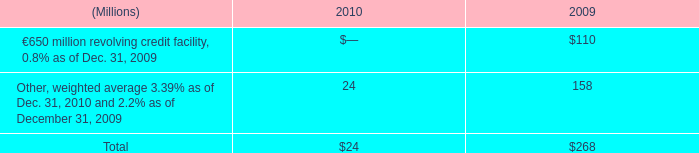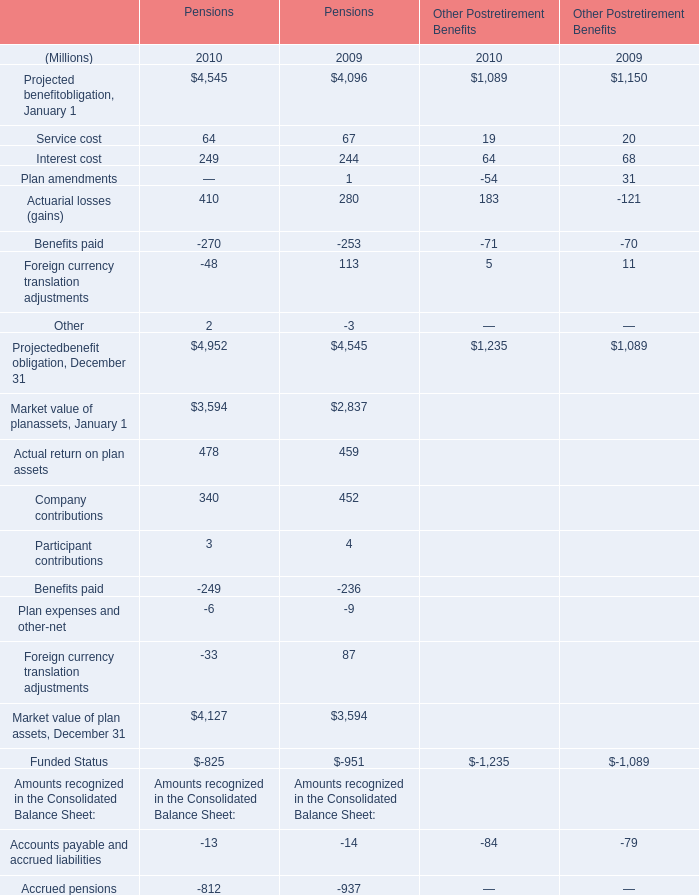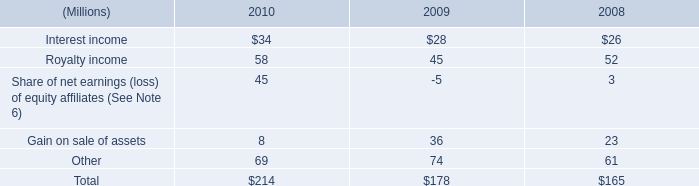what was the change in millions of interest payments from 2008 to 2009? 
Computations: (201 - 228)
Answer: -27.0. 